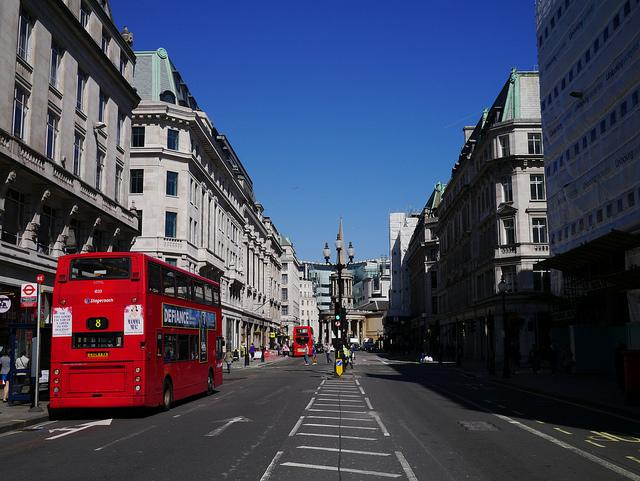How many double-decker buses are loading on the left side of the street? Please explain your reasoning. two. Two buses are on the road. 